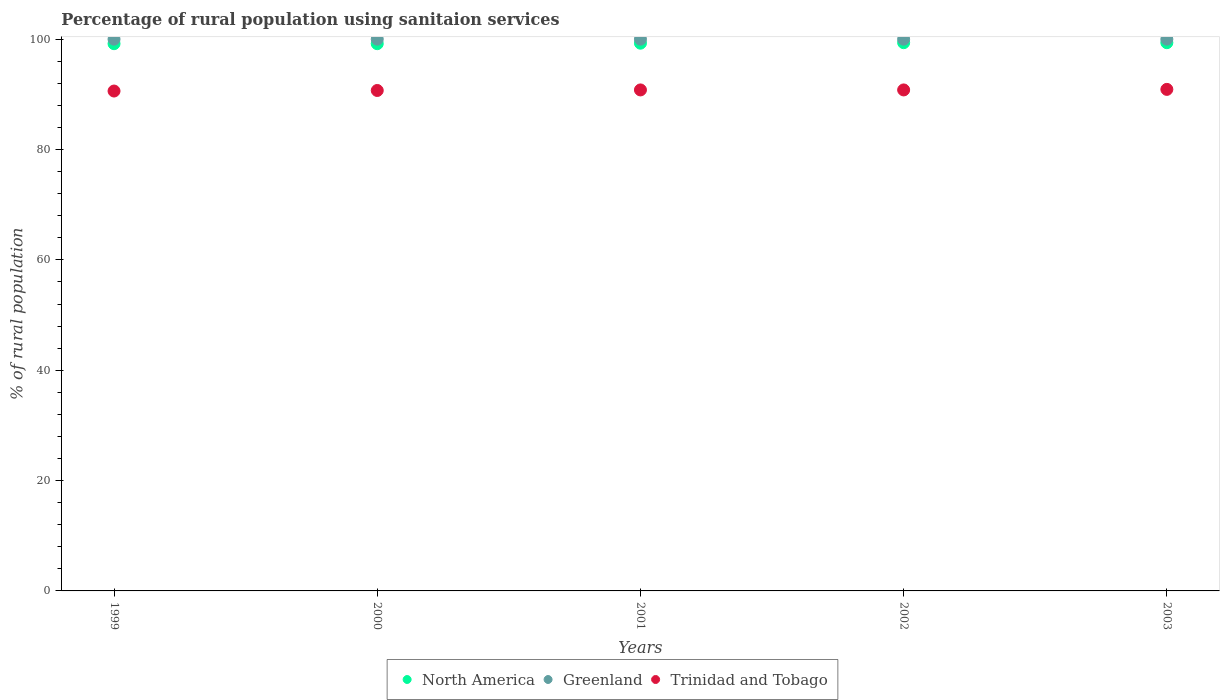What is the percentage of rural population using sanitaion services in Trinidad and Tobago in 1999?
Ensure brevity in your answer.  90.6. Across all years, what is the maximum percentage of rural population using sanitaion services in Greenland?
Give a very brief answer. 100. Across all years, what is the minimum percentage of rural population using sanitaion services in Trinidad and Tobago?
Ensure brevity in your answer.  90.6. What is the total percentage of rural population using sanitaion services in Trinidad and Tobago in the graph?
Provide a succinct answer. 453.8. What is the difference between the percentage of rural population using sanitaion services in Trinidad and Tobago in 1999 and that in 2000?
Provide a short and direct response. -0.1. What is the difference between the percentage of rural population using sanitaion services in North America in 2002 and the percentage of rural population using sanitaion services in Greenland in 1999?
Give a very brief answer. -0.64. What is the average percentage of rural population using sanitaion services in North America per year?
Make the answer very short. 99.27. In the year 2000, what is the difference between the percentage of rural population using sanitaion services in Trinidad and Tobago and percentage of rural population using sanitaion services in North America?
Keep it short and to the point. -8.48. In how many years, is the percentage of rural population using sanitaion services in North America greater than 64 %?
Ensure brevity in your answer.  5. What is the ratio of the percentage of rural population using sanitaion services in North America in 1999 to that in 2001?
Offer a terse response. 1. Is the percentage of rural population using sanitaion services in Greenland in 2002 less than that in 2003?
Make the answer very short. No. Is the difference between the percentage of rural population using sanitaion services in Trinidad and Tobago in 2000 and 2002 greater than the difference between the percentage of rural population using sanitaion services in North America in 2000 and 2002?
Offer a very short reply. Yes. What is the difference between the highest and the second highest percentage of rural population using sanitaion services in Trinidad and Tobago?
Offer a terse response. 0.1. What is the difference between the highest and the lowest percentage of rural population using sanitaion services in Trinidad and Tobago?
Your response must be concise. 0.3. Does the percentage of rural population using sanitaion services in Trinidad and Tobago monotonically increase over the years?
Make the answer very short. No. Is the percentage of rural population using sanitaion services in North America strictly greater than the percentage of rural population using sanitaion services in Trinidad and Tobago over the years?
Your answer should be compact. Yes. What is the difference between two consecutive major ticks on the Y-axis?
Ensure brevity in your answer.  20. Are the values on the major ticks of Y-axis written in scientific E-notation?
Your answer should be compact. No. Does the graph contain any zero values?
Offer a terse response. No. How are the legend labels stacked?
Offer a terse response. Horizontal. What is the title of the graph?
Your answer should be compact. Percentage of rural population using sanitaion services. What is the label or title of the X-axis?
Offer a very short reply. Years. What is the label or title of the Y-axis?
Keep it short and to the point. % of rural population. What is the % of rural population of North America in 1999?
Offer a terse response. 99.18. What is the % of rural population of Trinidad and Tobago in 1999?
Your answer should be compact. 90.6. What is the % of rural population in North America in 2000?
Your answer should be compact. 99.18. What is the % of rural population in Trinidad and Tobago in 2000?
Provide a short and direct response. 90.7. What is the % of rural population in North America in 2001?
Ensure brevity in your answer.  99.27. What is the % of rural population of Greenland in 2001?
Make the answer very short. 100. What is the % of rural population in Trinidad and Tobago in 2001?
Provide a short and direct response. 90.8. What is the % of rural population in North America in 2002?
Offer a terse response. 99.36. What is the % of rural population in Trinidad and Tobago in 2002?
Offer a very short reply. 90.8. What is the % of rural population in North America in 2003?
Provide a short and direct response. 99.36. What is the % of rural population of Trinidad and Tobago in 2003?
Your answer should be very brief. 90.9. Across all years, what is the maximum % of rural population of North America?
Give a very brief answer. 99.36. Across all years, what is the maximum % of rural population in Greenland?
Keep it short and to the point. 100. Across all years, what is the maximum % of rural population in Trinidad and Tobago?
Make the answer very short. 90.9. Across all years, what is the minimum % of rural population in North America?
Your answer should be compact. 99.18. Across all years, what is the minimum % of rural population of Greenland?
Keep it short and to the point. 100. Across all years, what is the minimum % of rural population of Trinidad and Tobago?
Offer a very short reply. 90.6. What is the total % of rural population in North America in the graph?
Make the answer very short. 496.36. What is the total % of rural population of Trinidad and Tobago in the graph?
Offer a terse response. 453.8. What is the difference between the % of rural population of North America in 1999 and that in 2000?
Provide a succinct answer. -0. What is the difference between the % of rural population in North America in 1999 and that in 2001?
Provide a short and direct response. -0.09. What is the difference between the % of rural population of Trinidad and Tobago in 1999 and that in 2001?
Offer a very short reply. -0.2. What is the difference between the % of rural population of North America in 1999 and that in 2002?
Make the answer very short. -0.18. What is the difference between the % of rural population in Trinidad and Tobago in 1999 and that in 2002?
Your answer should be very brief. -0.2. What is the difference between the % of rural population in North America in 1999 and that in 2003?
Make the answer very short. -0.18. What is the difference between the % of rural population of North America in 2000 and that in 2001?
Provide a succinct answer. -0.09. What is the difference between the % of rural population in North America in 2000 and that in 2002?
Your response must be concise. -0.18. What is the difference between the % of rural population of Greenland in 2000 and that in 2002?
Provide a succinct answer. 0. What is the difference between the % of rural population of Trinidad and Tobago in 2000 and that in 2002?
Your answer should be very brief. -0.1. What is the difference between the % of rural population of North America in 2000 and that in 2003?
Your response must be concise. -0.18. What is the difference between the % of rural population in Trinidad and Tobago in 2000 and that in 2003?
Keep it short and to the point. -0.2. What is the difference between the % of rural population in North America in 2001 and that in 2002?
Provide a succinct answer. -0.09. What is the difference between the % of rural population of Greenland in 2001 and that in 2002?
Make the answer very short. 0. What is the difference between the % of rural population of Trinidad and Tobago in 2001 and that in 2002?
Provide a succinct answer. 0. What is the difference between the % of rural population of North America in 2001 and that in 2003?
Offer a terse response. -0.09. What is the difference between the % of rural population in Greenland in 2001 and that in 2003?
Give a very brief answer. 0. What is the difference between the % of rural population in Trinidad and Tobago in 2001 and that in 2003?
Give a very brief answer. -0.1. What is the difference between the % of rural population in Trinidad and Tobago in 2002 and that in 2003?
Your response must be concise. -0.1. What is the difference between the % of rural population in North America in 1999 and the % of rural population in Greenland in 2000?
Make the answer very short. -0.82. What is the difference between the % of rural population of North America in 1999 and the % of rural population of Trinidad and Tobago in 2000?
Make the answer very short. 8.48. What is the difference between the % of rural population in Greenland in 1999 and the % of rural population in Trinidad and Tobago in 2000?
Provide a succinct answer. 9.3. What is the difference between the % of rural population of North America in 1999 and the % of rural population of Greenland in 2001?
Keep it short and to the point. -0.82. What is the difference between the % of rural population in North America in 1999 and the % of rural population in Trinidad and Tobago in 2001?
Provide a succinct answer. 8.38. What is the difference between the % of rural population in Greenland in 1999 and the % of rural population in Trinidad and Tobago in 2001?
Make the answer very short. 9.2. What is the difference between the % of rural population of North America in 1999 and the % of rural population of Greenland in 2002?
Your response must be concise. -0.82. What is the difference between the % of rural population of North America in 1999 and the % of rural population of Trinidad and Tobago in 2002?
Provide a succinct answer. 8.38. What is the difference between the % of rural population of North America in 1999 and the % of rural population of Greenland in 2003?
Provide a succinct answer. -0.82. What is the difference between the % of rural population in North America in 1999 and the % of rural population in Trinidad and Tobago in 2003?
Offer a terse response. 8.28. What is the difference between the % of rural population in North America in 2000 and the % of rural population in Greenland in 2001?
Keep it short and to the point. -0.82. What is the difference between the % of rural population in North America in 2000 and the % of rural population in Trinidad and Tobago in 2001?
Provide a short and direct response. 8.38. What is the difference between the % of rural population in North America in 2000 and the % of rural population in Greenland in 2002?
Your response must be concise. -0.82. What is the difference between the % of rural population of North America in 2000 and the % of rural population of Trinidad and Tobago in 2002?
Offer a terse response. 8.38. What is the difference between the % of rural population in North America in 2000 and the % of rural population in Greenland in 2003?
Give a very brief answer. -0.82. What is the difference between the % of rural population in North America in 2000 and the % of rural population in Trinidad and Tobago in 2003?
Keep it short and to the point. 8.28. What is the difference between the % of rural population of Greenland in 2000 and the % of rural population of Trinidad and Tobago in 2003?
Give a very brief answer. 9.1. What is the difference between the % of rural population in North America in 2001 and the % of rural population in Greenland in 2002?
Give a very brief answer. -0.73. What is the difference between the % of rural population in North America in 2001 and the % of rural population in Trinidad and Tobago in 2002?
Your answer should be very brief. 8.47. What is the difference between the % of rural population in Greenland in 2001 and the % of rural population in Trinidad and Tobago in 2002?
Provide a succinct answer. 9.2. What is the difference between the % of rural population in North America in 2001 and the % of rural population in Greenland in 2003?
Your answer should be compact. -0.73. What is the difference between the % of rural population of North America in 2001 and the % of rural population of Trinidad and Tobago in 2003?
Provide a short and direct response. 8.37. What is the difference between the % of rural population of North America in 2002 and the % of rural population of Greenland in 2003?
Your answer should be compact. -0.64. What is the difference between the % of rural population of North America in 2002 and the % of rural population of Trinidad and Tobago in 2003?
Provide a short and direct response. 8.46. What is the difference between the % of rural population of Greenland in 2002 and the % of rural population of Trinidad and Tobago in 2003?
Make the answer very short. 9.1. What is the average % of rural population in North America per year?
Your answer should be compact. 99.27. What is the average % of rural population in Greenland per year?
Provide a succinct answer. 100. What is the average % of rural population in Trinidad and Tobago per year?
Provide a short and direct response. 90.76. In the year 1999, what is the difference between the % of rural population of North America and % of rural population of Greenland?
Ensure brevity in your answer.  -0.82. In the year 1999, what is the difference between the % of rural population of North America and % of rural population of Trinidad and Tobago?
Provide a short and direct response. 8.58. In the year 2000, what is the difference between the % of rural population in North America and % of rural population in Greenland?
Your answer should be very brief. -0.82. In the year 2000, what is the difference between the % of rural population of North America and % of rural population of Trinidad and Tobago?
Make the answer very short. 8.48. In the year 2001, what is the difference between the % of rural population in North America and % of rural population in Greenland?
Provide a succinct answer. -0.73. In the year 2001, what is the difference between the % of rural population of North America and % of rural population of Trinidad and Tobago?
Give a very brief answer. 8.47. In the year 2001, what is the difference between the % of rural population of Greenland and % of rural population of Trinidad and Tobago?
Provide a short and direct response. 9.2. In the year 2002, what is the difference between the % of rural population in North America and % of rural population in Greenland?
Provide a short and direct response. -0.64. In the year 2002, what is the difference between the % of rural population in North America and % of rural population in Trinidad and Tobago?
Your answer should be compact. 8.56. In the year 2002, what is the difference between the % of rural population of Greenland and % of rural population of Trinidad and Tobago?
Keep it short and to the point. 9.2. In the year 2003, what is the difference between the % of rural population of North America and % of rural population of Greenland?
Your answer should be compact. -0.64. In the year 2003, what is the difference between the % of rural population in North America and % of rural population in Trinidad and Tobago?
Provide a succinct answer. 8.46. What is the ratio of the % of rural population in North America in 1999 to that in 2002?
Offer a terse response. 1. What is the ratio of the % of rural population in Greenland in 1999 to that in 2002?
Offer a very short reply. 1. What is the ratio of the % of rural population of North America in 1999 to that in 2003?
Make the answer very short. 1. What is the ratio of the % of rural population of Greenland in 1999 to that in 2003?
Your answer should be compact. 1. What is the ratio of the % of rural population of Trinidad and Tobago in 2000 to that in 2001?
Offer a terse response. 1. What is the ratio of the % of rural population in Greenland in 2000 to that in 2002?
Ensure brevity in your answer.  1. What is the ratio of the % of rural population in Trinidad and Tobago in 2000 to that in 2002?
Offer a very short reply. 1. What is the ratio of the % of rural population in North America in 2000 to that in 2003?
Offer a very short reply. 1. What is the ratio of the % of rural population of Greenland in 2000 to that in 2003?
Make the answer very short. 1. What is the ratio of the % of rural population in Trinidad and Tobago in 2000 to that in 2003?
Provide a succinct answer. 1. What is the ratio of the % of rural population in North America in 2001 to that in 2002?
Keep it short and to the point. 1. What is the ratio of the % of rural population in Trinidad and Tobago in 2001 to that in 2002?
Provide a short and direct response. 1. What is the ratio of the % of rural population of North America in 2001 to that in 2003?
Make the answer very short. 1. What is the ratio of the % of rural population of North America in 2002 to that in 2003?
Offer a very short reply. 1. What is the ratio of the % of rural population in Trinidad and Tobago in 2002 to that in 2003?
Provide a short and direct response. 1. What is the difference between the highest and the second highest % of rural population of North America?
Keep it short and to the point. 0. What is the difference between the highest and the second highest % of rural population of Greenland?
Provide a short and direct response. 0. What is the difference between the highest and the second highest % of rural population in Trinidad and Tobago?
Make the answer very short. 0.1. What is the difference between the highest and the lowest % of rural population in North America?
Ensure brevity in your answer.  0.18. What is the difference between the highest and the lowest % of rural population of Greenland?
Your response must be concise. 0. What is the difference between the highest and the lowest % of rural population of Trinidad and Tobago?
Keep it short and to the point. 0.3. 